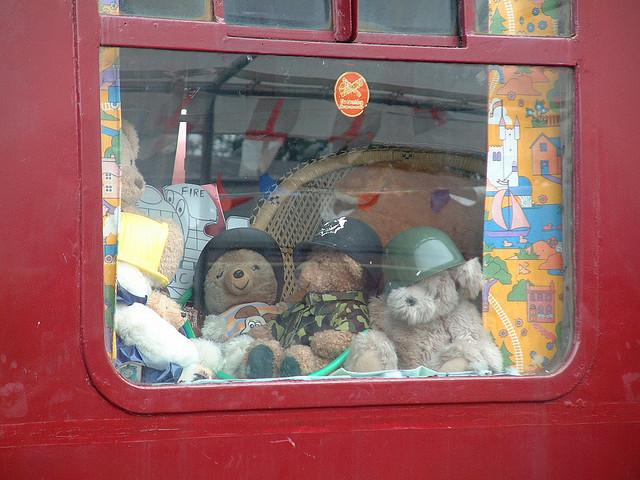What are the toys in the window called?

Choices:
A) footballs
B) barbie dolls
C) horseshoes
D) teddy bears teddy bears 